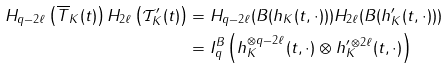Convert formula to latex. <formula><loc_0><loc_0><loc_500><loc_500>H _ { q - 2 \ell } \left ( \overline { T } _ { K } ( t ) \right ) H _ { 2 \ell } \left ( \mathcal { T } ^ { \prime } _ { K } ( t ) \right ) & = H _ { q - 2 \ell } ( B ( h _ { K } ( t , \cdot ) ) ) H _ { 2 \ell } ( B ( h ^ { \prime } _ { K } ( t , \cdot ) ) ) \\ & = I ^ { B } _ { q } \left ( h ^ { \otimes q - 2 \ell } _ { K } ( t , \cdot ) \otimes h ^ { \prime \, \otimes 2 \ell } _ { K } ( t , \cdot ) \right )</formula> 